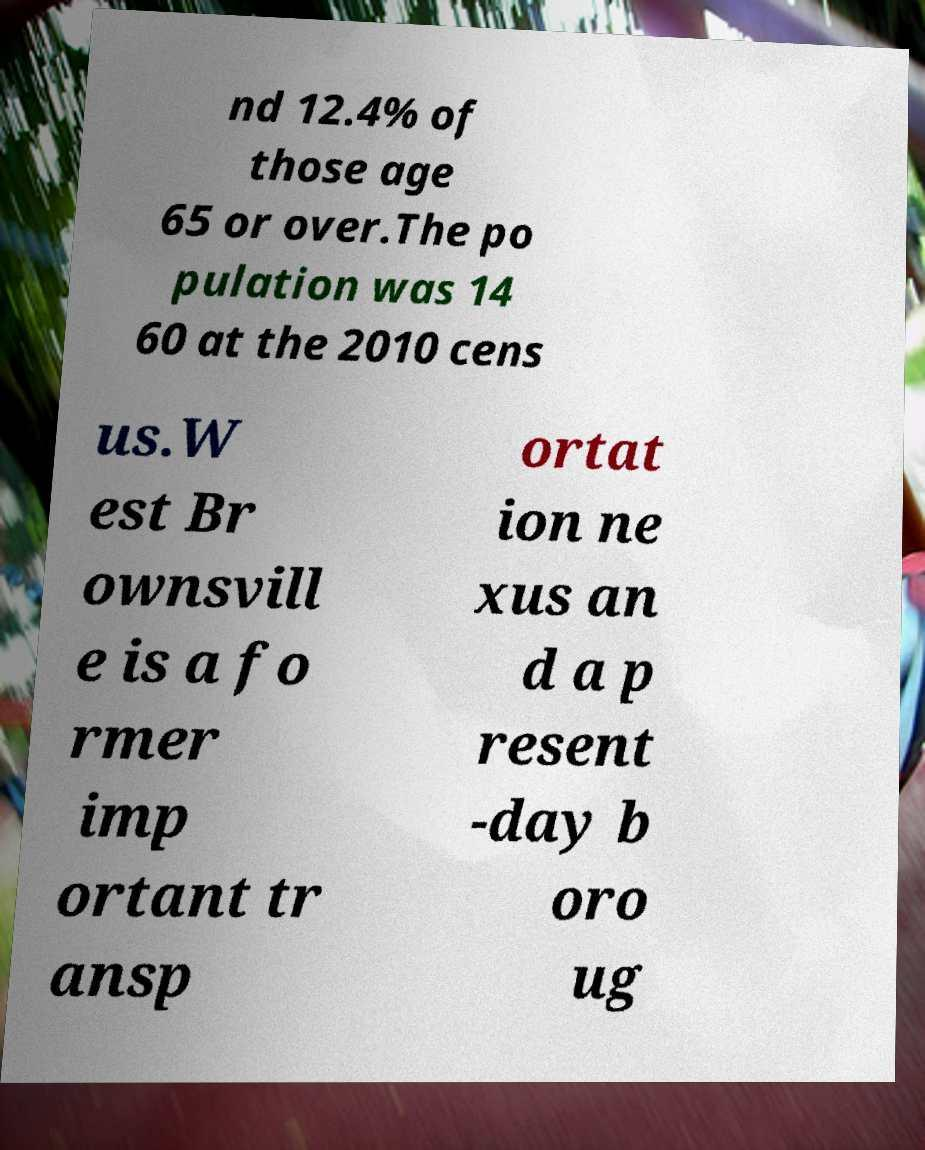Can you accurately transcribe the text from the provided image for me? nd 12.4% of those age 65 or over.The po pulation was 14 60 at the 2010 cens us.W est Br ownsvill e is a fo rmer imp ortant tr ansp ortat ion ne xus an d a p resent -day b oro ug 